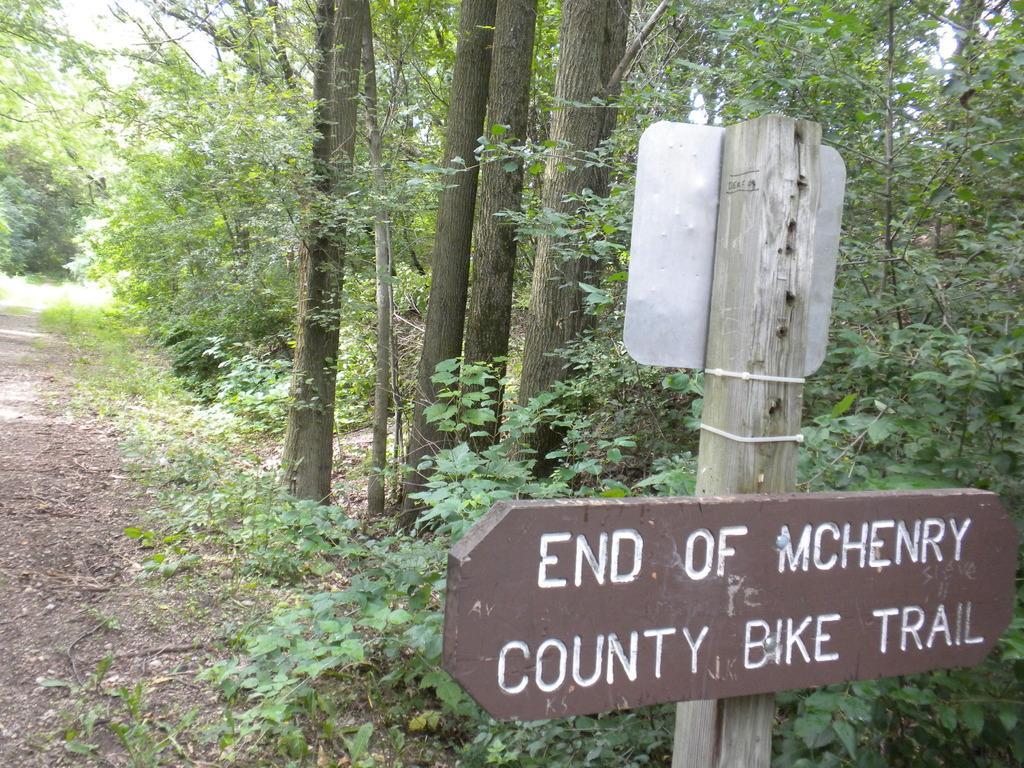Describe this image in one or two sentences. On the right side of the image we can see few sign boards, in the background we can find few plants and trees. 